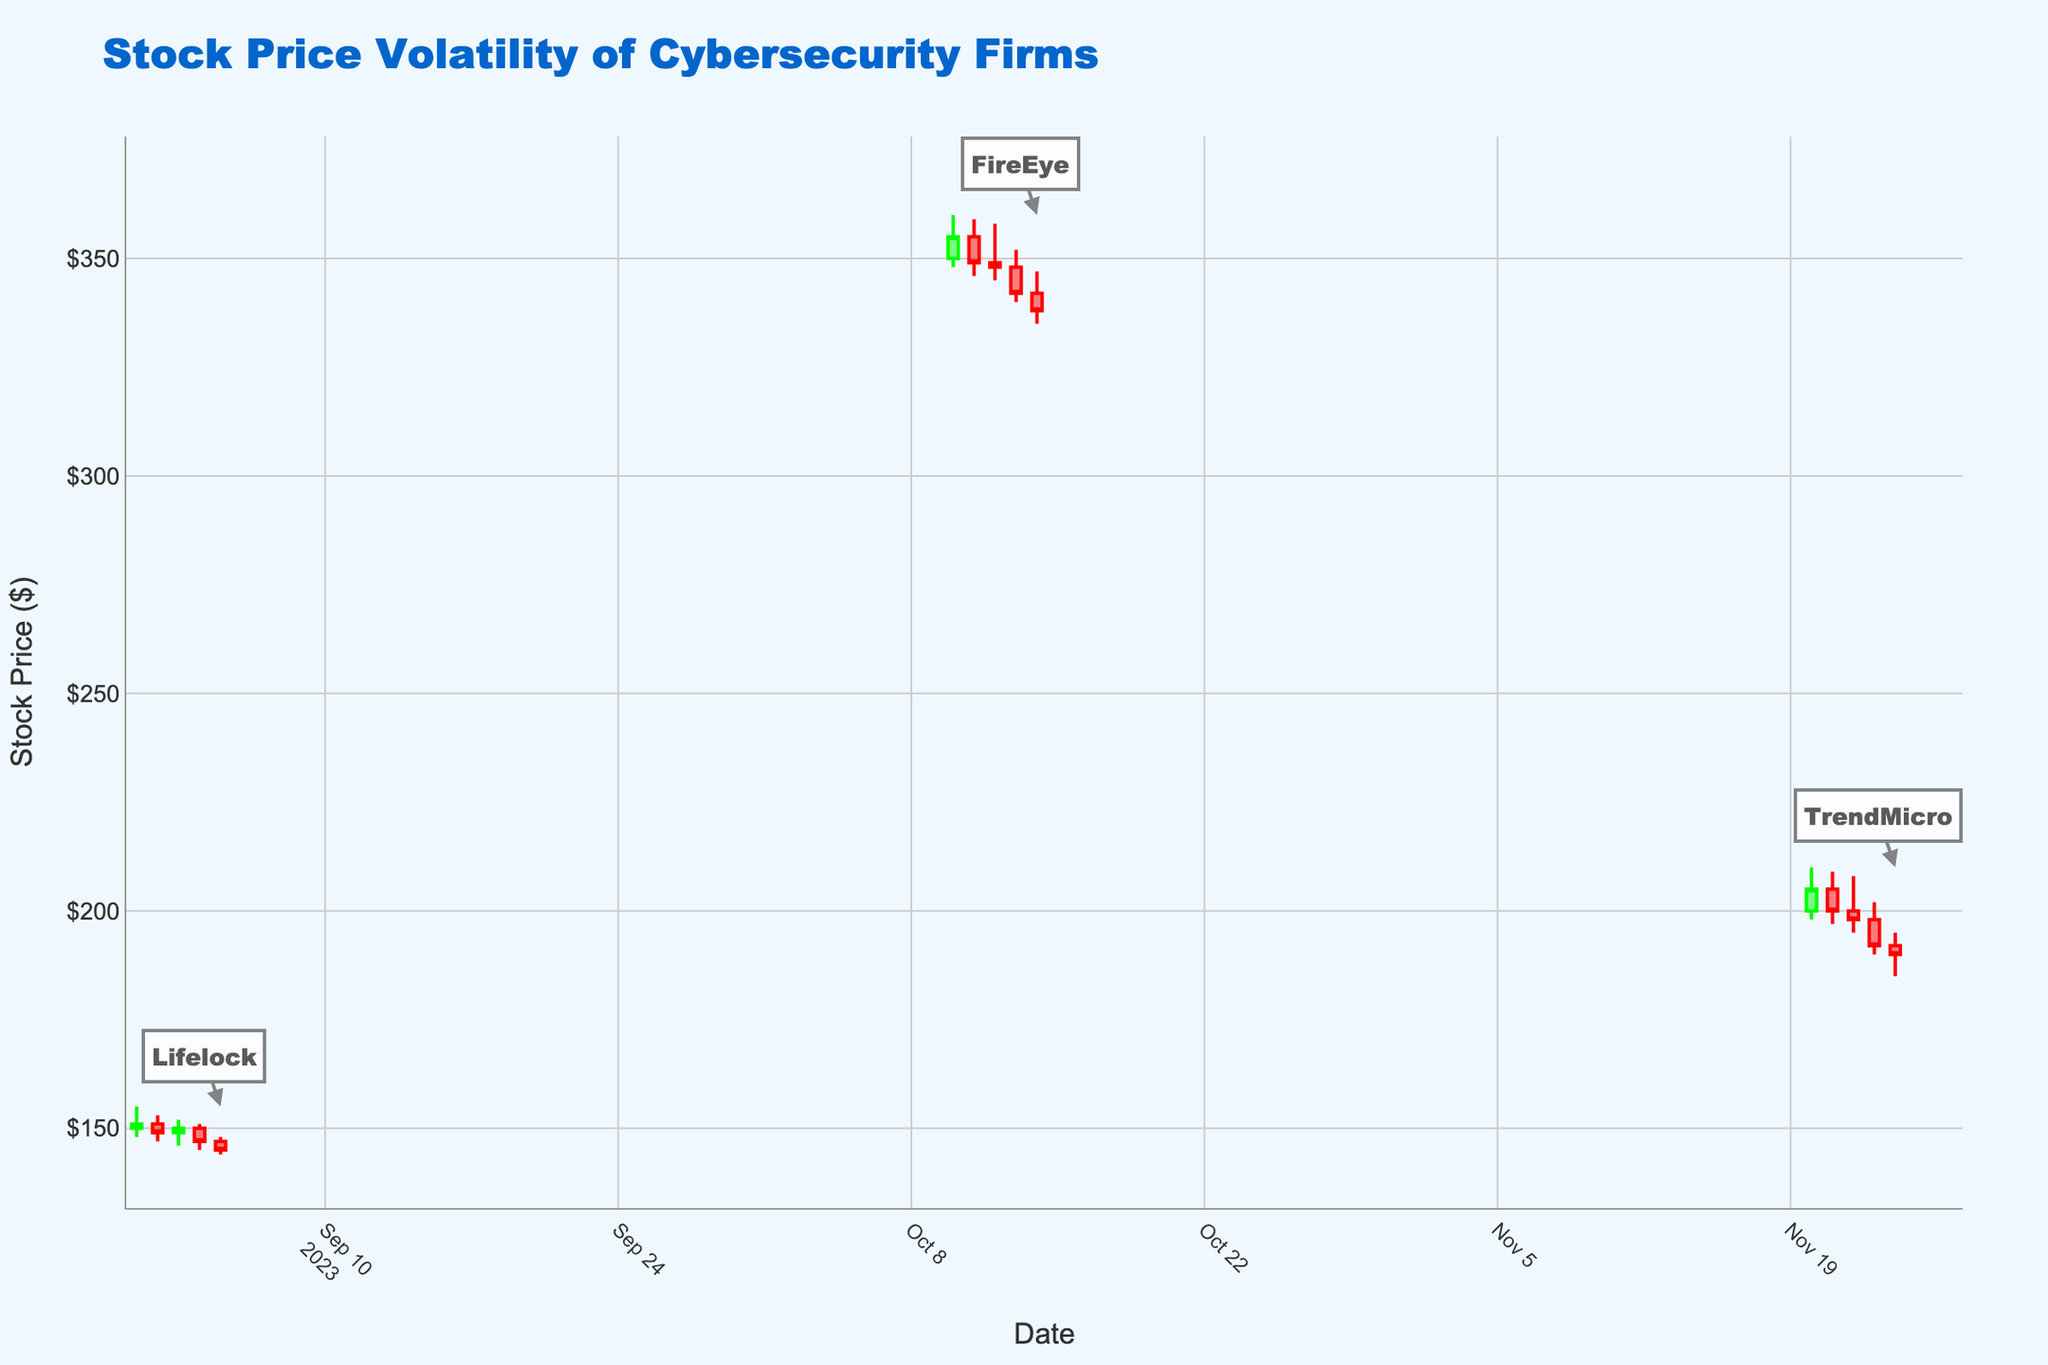What is the title of the figure? The title is usually displayed at the top of the chart. In this figure, it is well-defined and uniquely indicates the subject of the chart.
Answer: Stock Price Volatility of Cybersecurity Firms What time period does the figure cover for Lifelock's stock prices? By examining the x-axis labels and the data points, we can determine the span of dates shown specifically for Lifelock. The dates for Lifelock range from September 1 to September 5.
Answer: September 1 to September 5, 2023 How does the stock price of FireEye change from October 10 to October 14? We check the position and movement of the candlesticks for FireEye from October 10 to October 14. On October 10, the close is higher than subsequent dates, indicating a general downward trend over these days.
Answer: It decreases What was the closing stock price of TrendMicro on November 24, 2023? The closing price is the final price of the stock on a given day. By looking at the last candlestick representing November 24, we identify its close value.
Answer: $190 Which company witnessed the highest high price post-breach and what was the value? By looking at all the candlesticks and comparing their heights, we find the highest point among them.
Answer: FireEye, $360 What is the volume trend for Lifelock from September 1 to September 5, 2023? We observe the volume values beneath each candlestick for Lifelock over the specified dates. The trend shows the volume increases consistently for Lifelock.
Answer: Increasing Which company had the largest percentage drop in closing price from the day after the breach to the fifth day following the breach? Calculate the percentage difference for each company from their closing prices the day after the breach to the fifth day. Compare these percentages to find the largest drop.
Answer: FireEye What is the color of the lines for the days when the closing price increased? The color representing increasing closing prices is specified in the chart description. We note that it is typically a greenish color.
Answer: Green Among the three companies, which had the lowest closing price on any given day post-breach and what was the value? Compare the closing prices of all three companies on individual days to find the lowest one.
Answer: Lifelock, $145 Which company's annotations appear highest on the figure? The annotations' positions correlate with the relative placement of the highest stock prices. Thus, the company with the highest stock price annotation is identified.
Answer: FireEye 